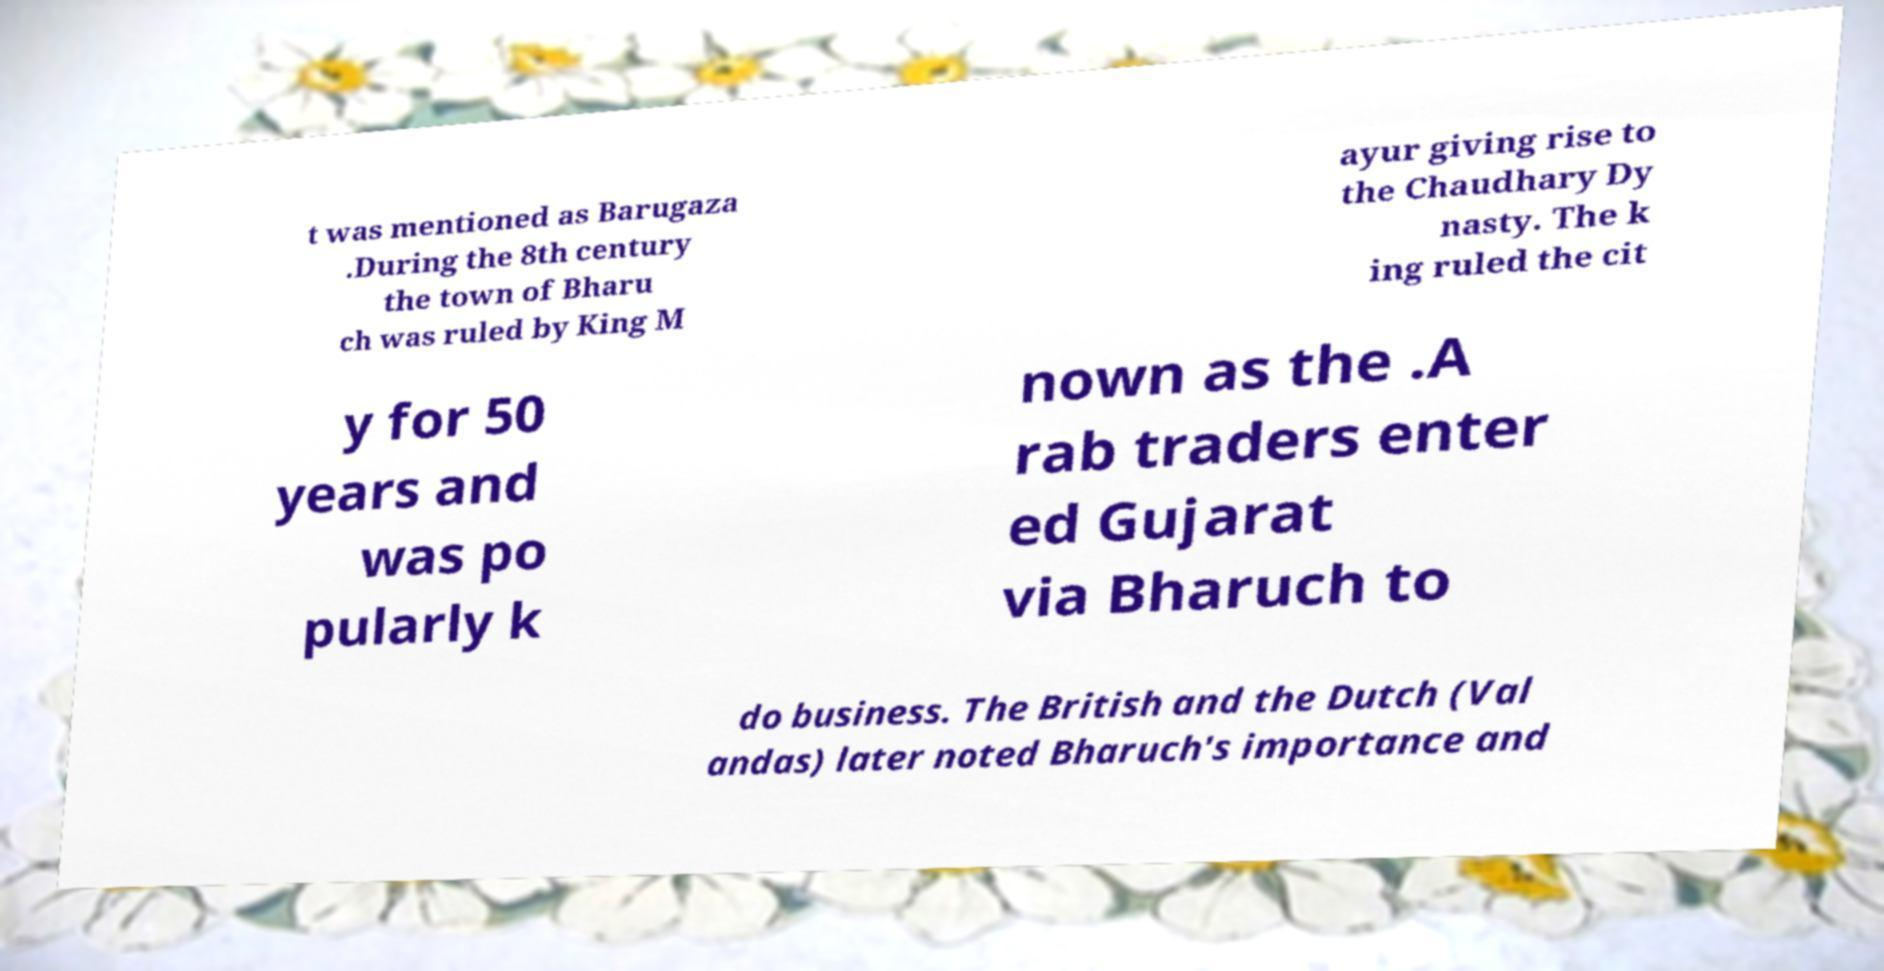For documentation purposes, I need the text within this image transcribed. Could you provide that? t was mentioned as Barugaza .During the 8th century the town of Bharu ch was ruled by King M ayur giving rise to the Chaudhary Dy nasty. The k ing ruled the cit y for 50 years and was po pularly k nown as the .A rab traders enter ed Gujarat via Bharuch to do business. The British and the Dutch (Val andas) later noted Bharuch's importance and 